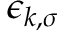<formula> <loc_0><loc_0><loc_500><loc_500>\epsilon _ { k , \sigma }</formula> 